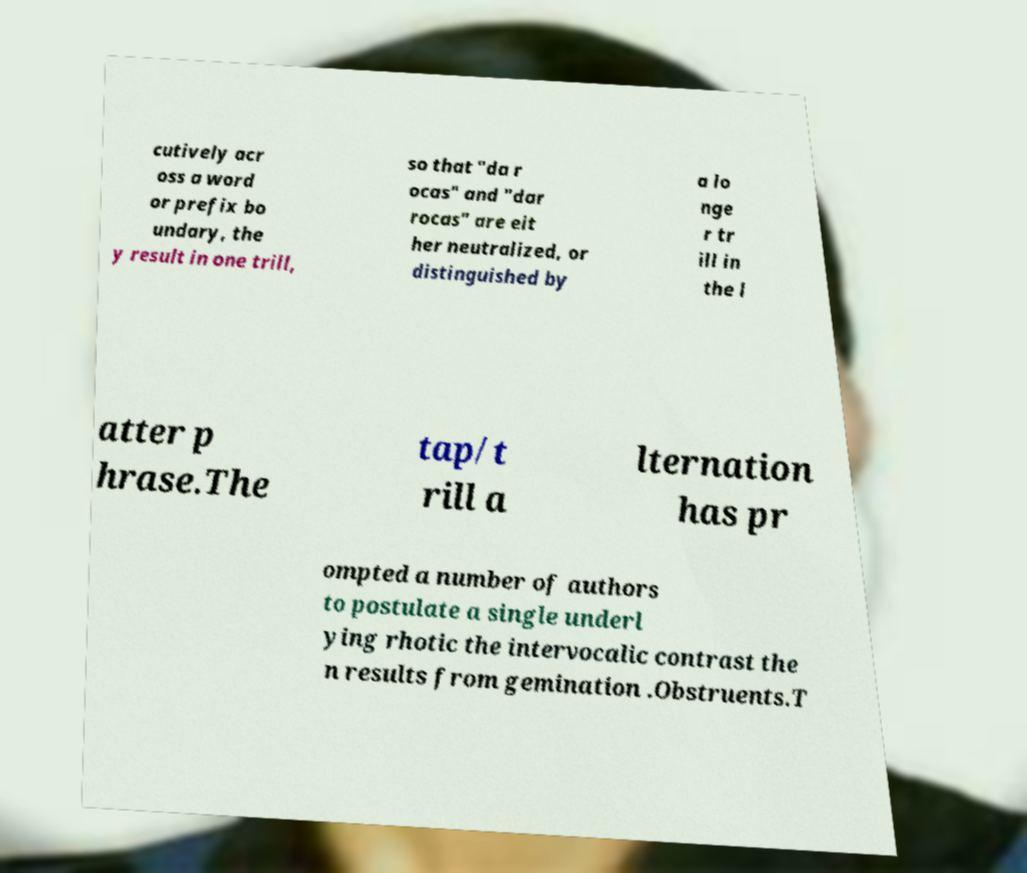Could you assist in decoding the text presented in this image and type it out clearly? cutively acr oss a word or prefix bo undary, the y result in one trill, so that "da r ocas" and "dar rocas" are eit her neutralized, or distinguished by a lo nge r tr ill in the l atter p hrase.The tap/t rill a lternation has pr ompted a number of authors to postulate a single underl ying rhotic the intervocalic contrast the n results from gemination .Obstruents.T 